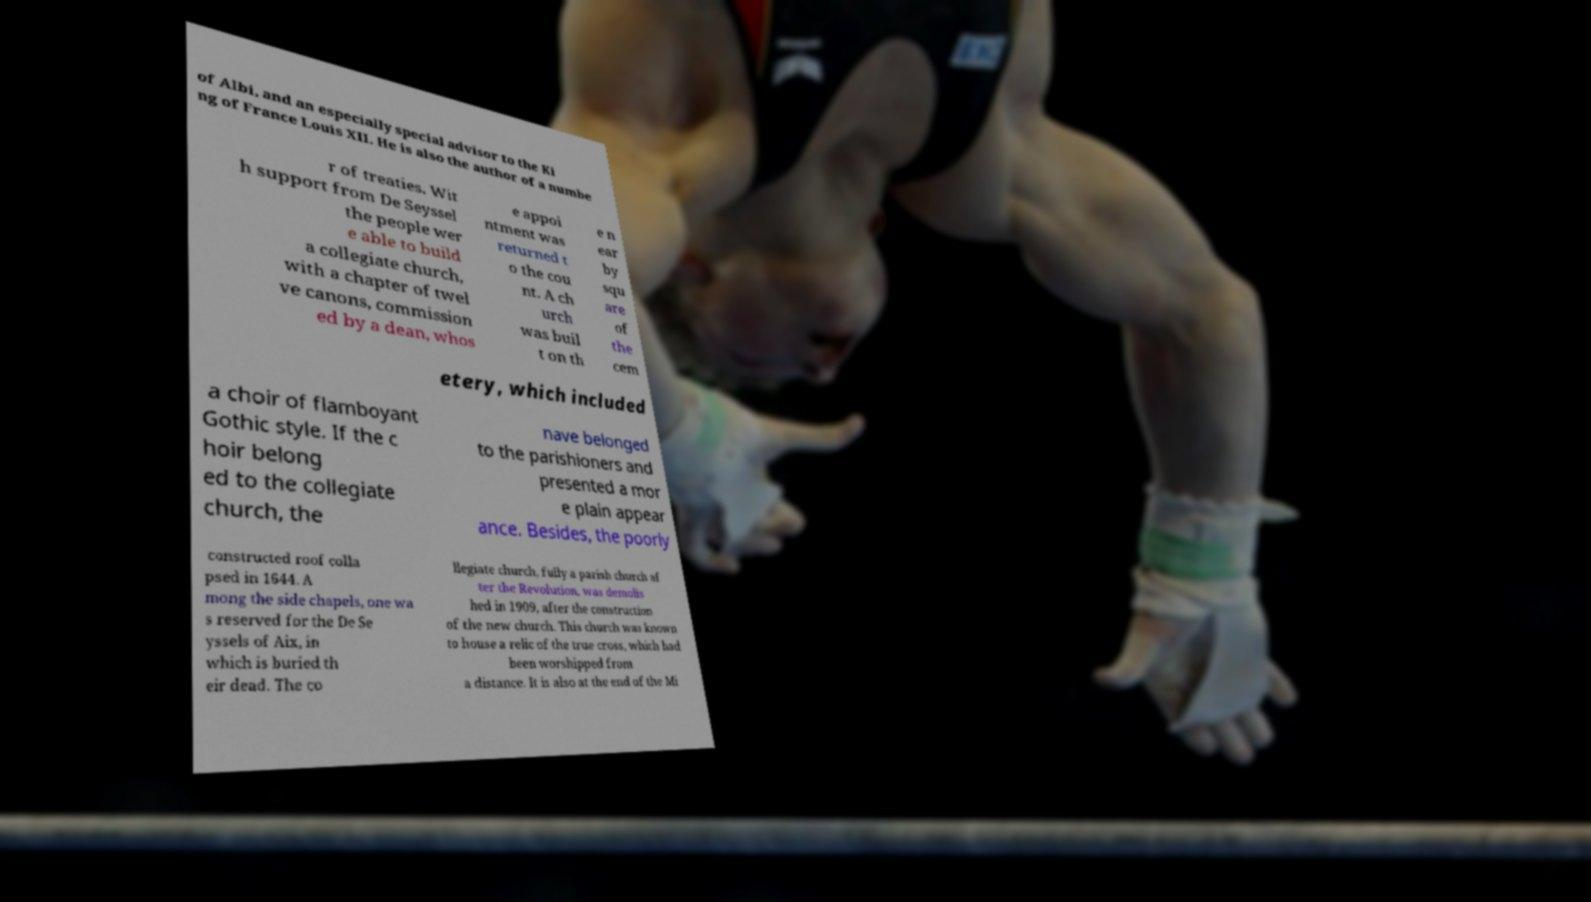There's text embedded in this image that I need extracted. Can you transcribe it verbatim? of Albi, and an especially special advisor to the Ki ng of France Louis XII. He is also the author of a numbe r of treaties. Wit h support from De Seyssel the people wer e able to build a collegiate church, with a chapter of twel ve canons, commission ed by a dean, whos e appoi ntment was returned t o the cou nt. A ch urch was buil t on th e n ear by squ are of the cem etery, which included a choir of flamboyant Gothic style. If the c hoir belong ed to the collegiate church, the nave belonged to the parishioners and presented a mor e plain appear ance. Besides, the poorly constructed roof colla psed in 1644. A mong the side chapels, one wa s reserved for the De Se yssels of Aix, in which is buried th eir dead. The co llegiate church, fully a parish church af ter the Revolution, was demolis hed in 1909, after the construction of the new church. This church was known to house a relic of the true cross, which had been worshipped from a distance. It is also at the end of the Mi 